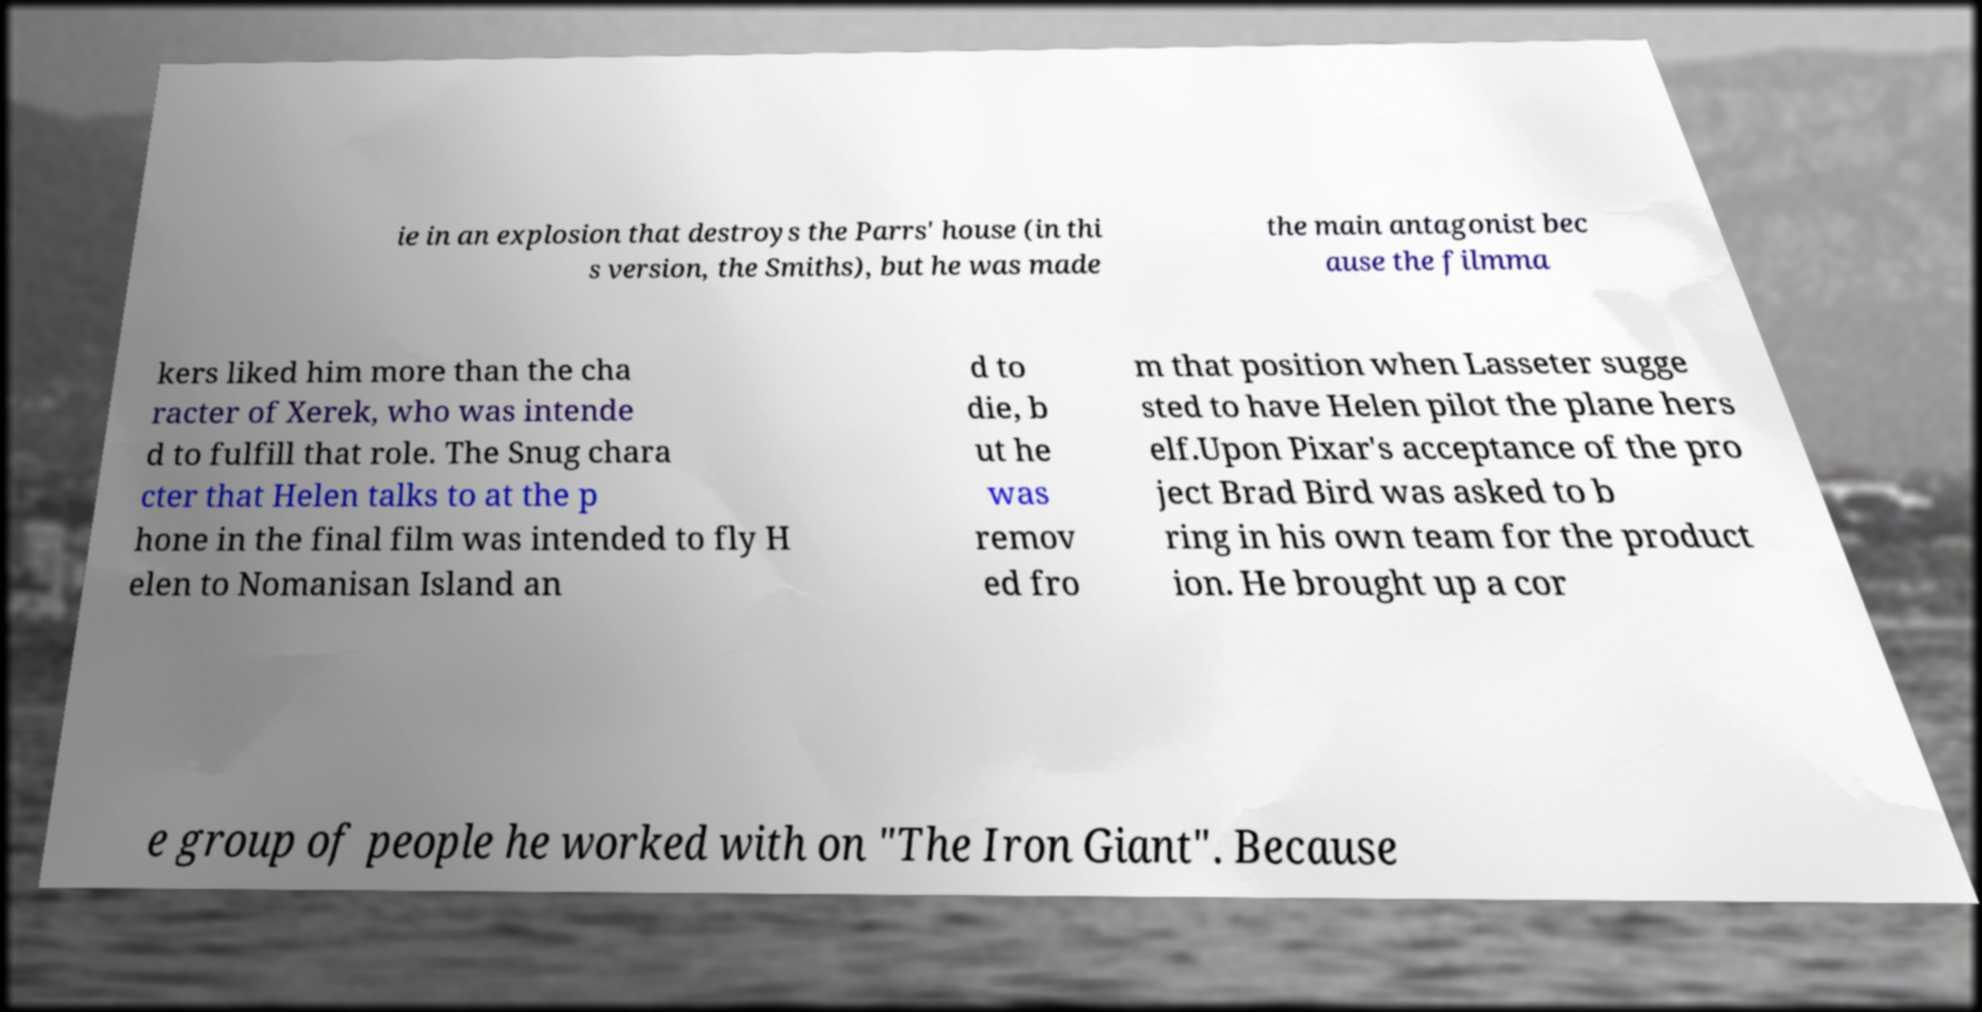Please identify and transcribe the text found in this image. ie in an explosion that destroys the Parrs' house (in thi s version, the Smiths), but he was made the main antagonist bec ause the filmma kers liked him more than the cha racter of Xerek, who was intende d to fulfill that role. The Snug chara cter that Helen talks to at the p hone in the final film was intended to fly H elen to Nomanisan Island an d to die, b ut he was remov ed fro m that position when Lasseter sugge sted to have Helen pilot the plane hers elf.Upon Pixar's acceptance of the pro ject Brad Bird was asked to b ring in his own team for the product ion. He brought up a cor e group of people he worked with on "The Iron Giant". Because 